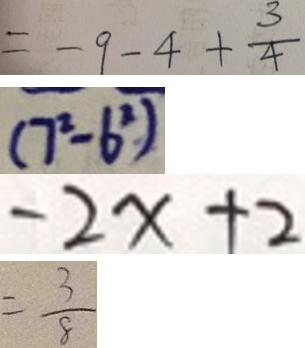<formula> <loc_0><loc_0><loc_500><loc_500>= - 9 - 4 + \frac { 3 } { 4 } 
 ( 7 ^ { 2 } - 6 ^ { 2 } ) 
 - 2 x + 2 
 = \frac { 3 } { 8 }</formula> 